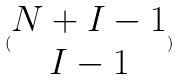<formula> <loc_0><loc_0><loc_500><loc_500>( \begin{matrix} N + I - 1 \\ I - 1 \end{matrix} )</formula> 